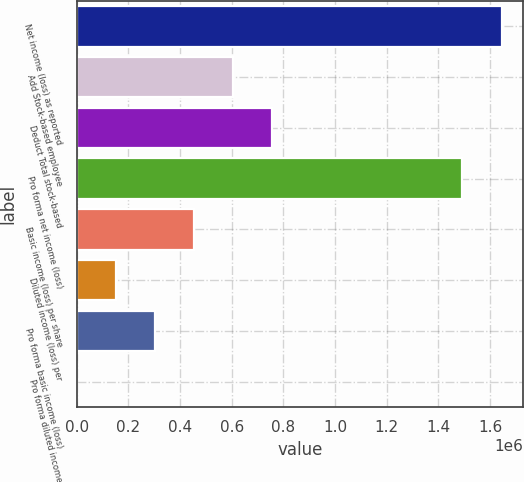Convert chart to OTSL. <chart><loc_0><loc_0><loc_500><loc_500><bar_chart><fcel>Net income (loss) as reported<fcel>Add Stock-based employee<fcel>Deduct Total stock-based<fcel>Pro forma net income (loss)<fcel>Basic income (loss) per share<fcel>Diluted income (loss) per<fcel>Pro forma basic income (loss)<fcel>Pro forma diluted income<nl><fcel>1.64436e+06<fcel>605818<fcel>757272<fcel>1.49291e+06<fcel>454364<fcel>151457<fcel>302911<fcel>3.18<nl></chart> 